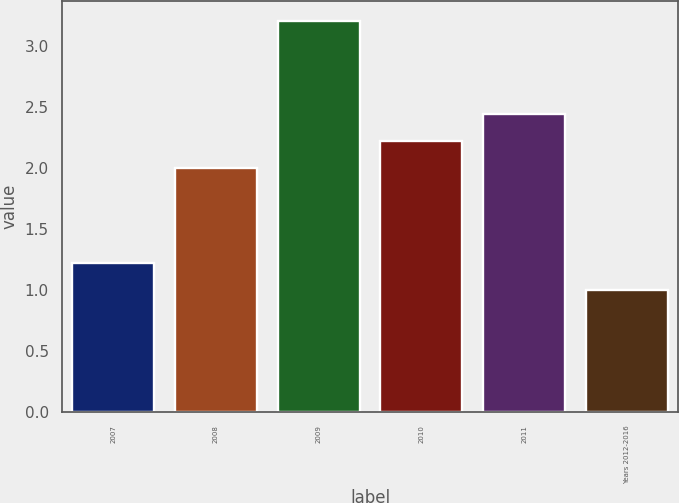<chart> <loc_0><loc_0><loc_500><loc_500><bar_chart><fcel>2007<fcel>2008<fcel>2009<fcel>2010<fcel>2011<fcel>Years 2012-2016<nl><fcel>1.22<fcel>2<fcel>3.21<fcel>2.22<fcel>2.44<fcel>1<nl></chart> 